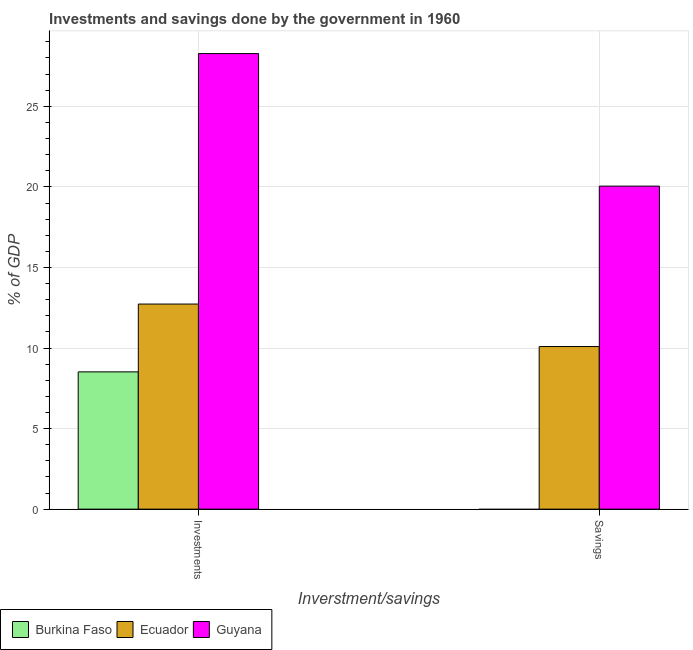How many groups of bars are there?
Your answer should be compact. 2. Are the number of bars per tick equal to the number of legend labels?
Provide a short and direct response. No. How many bars are there on the 1st tick from the left?
Your response must be concise. 3. What is the label of the 2nd group of bars from the left?
Provide a short and direct response. Savings. What is the savings of government in Guyana?
Offer a very short reply. 20.05. Across all countries, what is the maximum savings of government?
Your answer should be compact. 20.05. In which country was the savings of government maximum?
Provide a succinct answer. Guyana. What is the total savings of government in the graph?
Provide a short and direct response. 30.14. What is the difference between the savings of government in Guyana and that in Ecuador?
Give a very brief answer. 9.96. What is the difference between the investments of government in Guyana and the savings of government in Burkina Faso?
Offer a very short reply. 28.27. What is the average savings of government per country?
Keep it short and to the point. 10.05. What is the difference between the investments of government and savings of government in Guyana?
Ensure brevity in your answer.  8.22. What is the ratio of the investments of government in Burkina Faso to that in Ecuador?
Make the answer very short. 0.67. Is the investments of government in Guyana less than that in Burkina Faso?
Your response must be concise. No. In how many countries, is the savings of government greater than the average savings of government taken over all countries?
Offer a terse response. 2. How many bars are there?
Keep it short and to the point. 5. Are all the bars in the graph horizontal?
Your response must be concise. No. How many countries are there in the graph?
Your answer should be compact. 3. What is the difference between two consecutive major ticks on the Y-axis?
Offer a very short reply. 5. Are the values on the major ticks of Y-axis written in scientific E-notation?
Provide a short and direct response. No. How are the legend labels stacked?
Make the answer very short. Horizontal. What is the title of the graph?
Your response must be concise. Investments and savings done by the government in 1960. Does "New Caledonia" appear as one of the legend labels in the graph?
Your answer should be very brief. No. What is the label or title of the X-axis?
Give a very brief answer. Inverstment/savings. What is the label or title of the Y-axis?
Ensure brevity in your answer.  % of GDP. What is the % of GDP of Burkina Faso in Investments?
Make the answer very short. 8.52. What is the % of GDP in Ecuador in Investments?
Your response must be concise. 12.73. What is the % of GDP in Guyana in Investments?
Provide a short and direct response. 28.27. What is the % of GDP in Burkina Faso in Savings?
Provide a succinct answer. 0. What is the % of GDP in Ecuador in Savings?
Keep it short and to the point. 10.09. What is the % of GDP in Guyana in Savings?
Your answer should be compact. 20.05. Across all Inverstment/savings, what is the maximum % of GDP of Burkina Faso?
Give a very brief answer. 8.52. Across all Inverstment/savings, what is the maximum % of GDP of Ecuador?
Provide a succinct answer. 12.73. Across all Inverstment/savings, what is the maximum % of GDP in Guyana?
Ensure brevity in your answer.  28.27. Across all Inverstment/savings, what is the minimum % of GDP in Ecuador?
Your response must be concise. 10.09. Across all Inverstment/savings, what is the minimum % of GDP in Guyana?
Provide a short and direct response. 20.05. What is the total % of GDP in Burkina Faso in the graph?
Your answer should be compact. 8.52. What is the total % of GDP in Ecuador in the graph?
Give a very brief answer. 22.82. What is the total % of GDP in Guyana in the graph?
Your answer should be compact. 48.32. What is the difference between the % of GDP of Ecuador in Investments and that in Savings?
Make the answer very short. 2.64. What is the difference between the % of GDP of Guyana in Investments and that in Savings?
Offer a very short reply. 8.22. What is the difference between the % of GDP in Burkina Faso in Investments and the % of GDP in Ecuador in Savings?
Provide a succinct answer. -1.57. What is the difference between the % of GDP of Burkina Faso in Investments and the % of GDP of Guyana in Savings?
Make the answer very short. -11.53. What is the difference between the % of GDP in Ecuador in Investments and the % of GDP in Guyana in Savings?
Ensure brevity in your answer.  -7.32. What is the average % of GDP in Burkina Faso per Inverstment/savings?
Provide a short and direct response. 4.26. What is the average % of GDP of Ecuador per Inverstment/savings?
Offer a very short reply. 11.41. What is the average % of GDP in Guyana per Inverstment/savings?
Keep it short and to the point. 24.16. What is the difference between the % of GDP of Burkina Faso and % of GDP of Ecuador in Investments?
Your answer should be very brief. -4.21. What is the difference between the % of GDP in Burkina Faso and % of GDP in Guyana in Investments?
Make the answer very short. -19.75. What is the difference between the % of GDP in Ecuador and % of GDP in Guyana in Investments?
Your answer should be very brief. -15.54. What is the difference between the % of GDP of Ecuador and % of GDP of Guyana in Savings?
Your response must be concise. -9.96. What is the ratio of the % of GDP of Ecuador in Investments to that in Savings?
Provide a short and direct response. 1.26. What is the ratio of the % of GDP in Guyana in Investments to that in Savings?
Keep it short and to the point. 1.41. What is the difference between the highest and the second highest % of GDP in Ecuador?
Give a very brief answer. 2.64. What is the difference between the highest and the second highest % of GDP in Guyana?
Keep it short and to the point. 8.22. What is the difference between the highest and the lowest % of GDP in Burkina Faso?
Give a very brief answer. 8.52. What is the difference between the highest and the lowest % of GDP of Ecuador?
Offer a very short reply. 2.64. What is the difference between the highest and the lowest % of GDP of Guyana?
Ensure brevity in your answer.  8.22. 